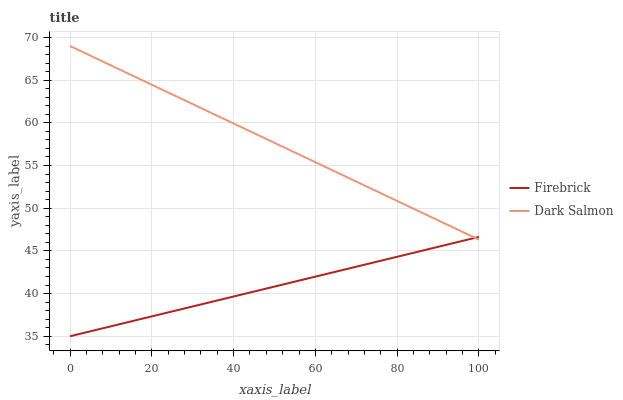Does Firebrick have the minimum area under the curve?
Answer yes or no. Yes. Does Dark Salmon have the maximum area under the curve?
Answer yes or no. Yes. Does Dark Salmon have the minimum area under the curve?
Answer yes or no. No. Is Firebrick the smoothest?
Answer yes or no. Yes. Is Dark Salmon the roughest?
Answer yes or no. Yes. Is Dark Salmon the smoothest?
Answer yes or no. No. Does Firebrick have the lowest value?
Answer yes or no. Yes. Does Dark Salmon have the lowest value?
Answer yes or no. No. Does Dark Salmon have the highest value?
Answer yes or no. Yes. Does Dark Salmon intersect Firebrick?
Answer yes or no. Yes. Is Dark Salmon less than Firebrick?
Answer yes or no. No. Is Dark Salmon greater than Firebrick?
Answer yes or no. No. 